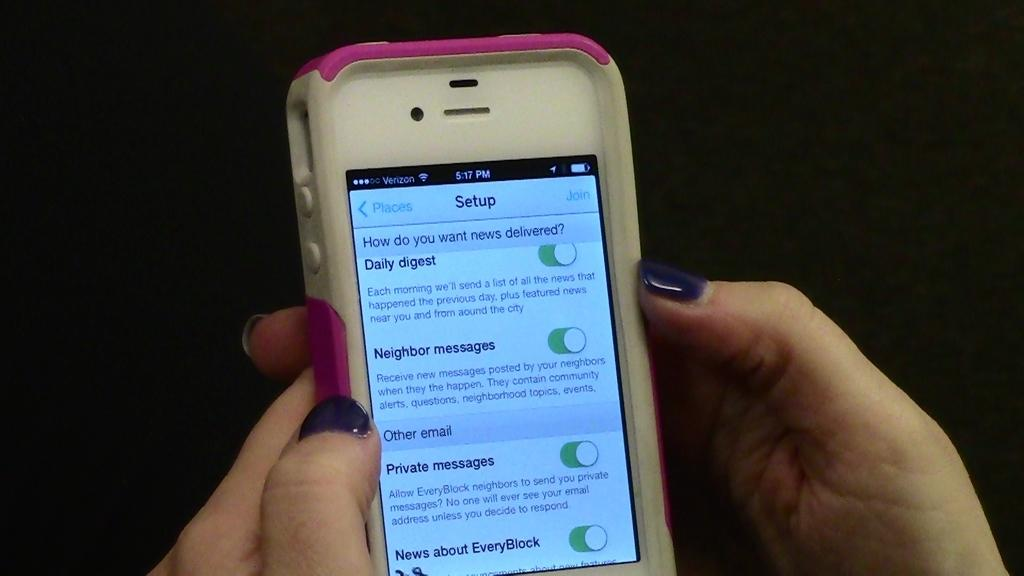Provide a one-sentence caption for the provided image. Someone holding a white and pink cell phone with a Setup Screen asking how do you want your news delivered. 